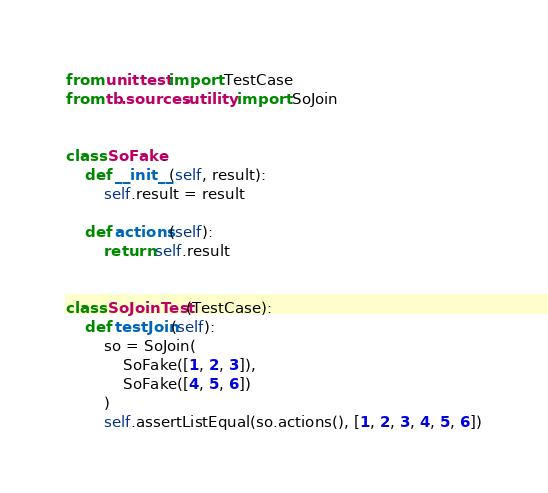<code> <loc_0><loc_0><loc_500><loc_500><_Python_>from unittest import TestCase
from tb.sources.utility import SoJoin


class SoFake:
	def __init__(self, result):
		self.result = result

	def actions(self):
		return self.result


class SoJoinTest(TestCase):
	def testJoin(self):
		so = SoJoin(
			SoFake([1, 2, 3]),
			SoFake([4, 5, 6])
		)
		self.assertListEqual(so.actions(), [1, 2, 3, 4, 5, 6])
</code> 